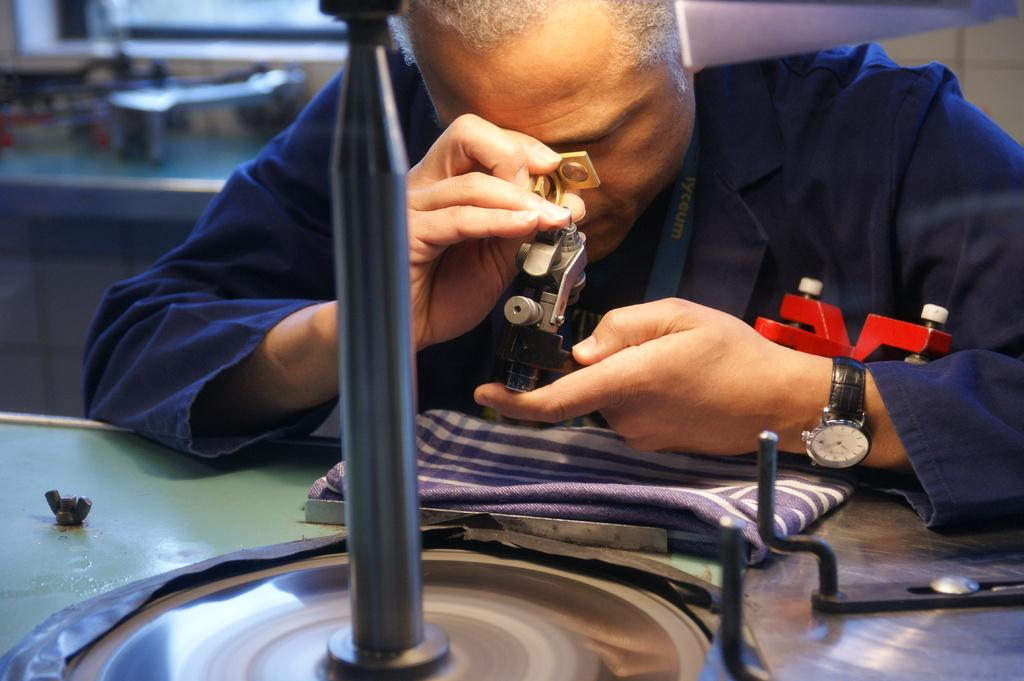Who or what is present in the image? There is a person in the image. What is the person doing in the image? The person is holding an object. What is the object on the table in the image? There is a table in the image, and it has a cloth on it. There are also objects on the table. What is the cabinet in the image used for? The cabinet in the image has objects on it, suggesting it is used for storage. What type of cake is being used as a cloth for the table in the image? There is no cake present in the image; the table has a cloth on it. What type of silk is draped over the cabinet in the image? There is no silk present in the image; the cabinet has objects on it. 